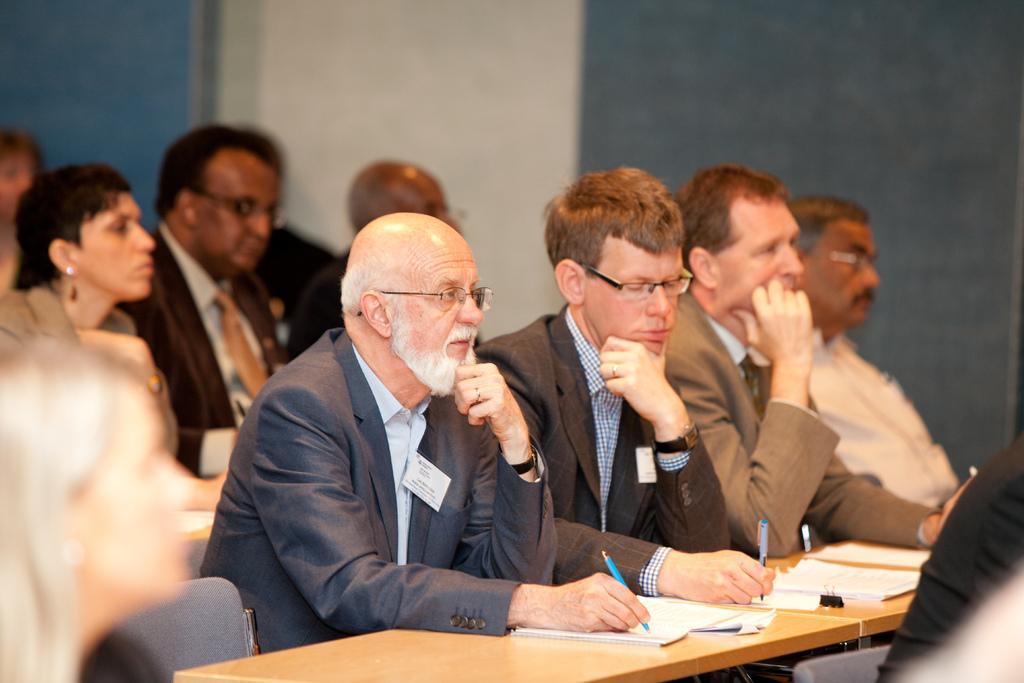Can you describe this image briefly? In this image I can see a group of people sitting. I can see some objects on the table. In the background, I can see the wall. 